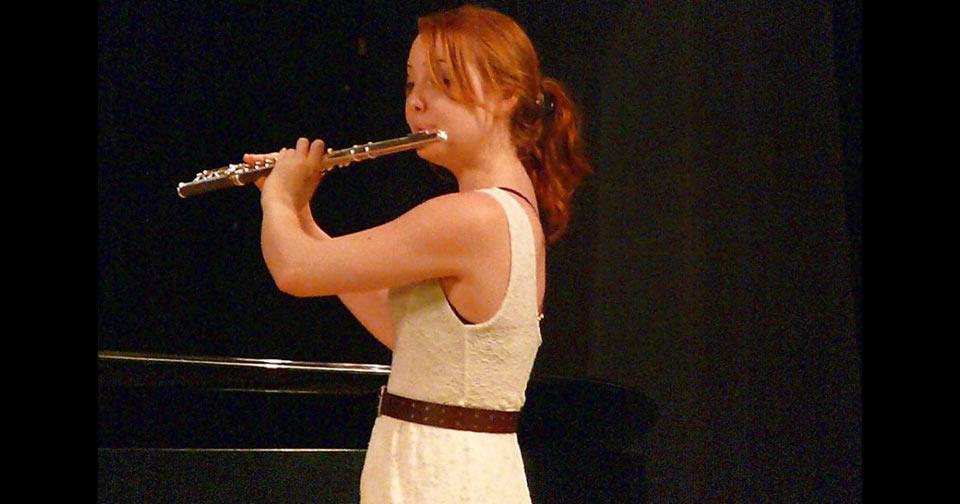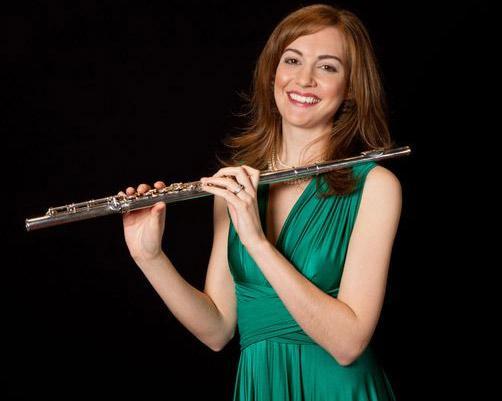The first image is the image on the left, the second image is the image on the right. For the images displayed, is the sentence "In at least one image there is a woman with long hair  holding but no playing the flute." factually correct? Answer yes or no. Yes. The first image is the image on the left, the second image is the image on the right. Evaluate the accuracy of this statement regarding the images: "A woman smiles while she holds a flute in one of the images.". Is it true? Answer yes or no. Yes. 